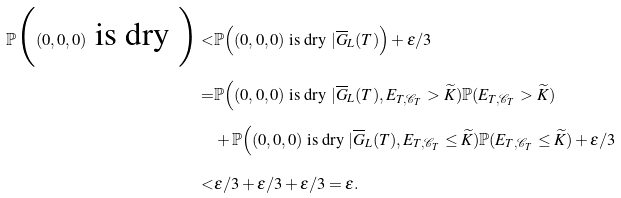Convert formula to latex. <formula><loc_0><loc_0><loc_500><loc_500>\mathbb { P } \Big ( ( 0 , 0 , 0 ) \text { is dry } \Big ) < & \mathbb { P } \Big ( ( 0 , 0 , 0 ) \text { is dry } | \overline { G } _ { L } ( T ) \Big ) + \epsilon / 3 \\ = & \mathbb { P } \Big ( ( 0 , 0 , 0 ) \text { is dry } | \overline { G } _ { L } ( T ) , E _ { T , \mathcal { C } _ { T } } > \widetilde { K } ) \mathbb { P } ( E _ { T , \mathcal { C } _ { T } } > \widetilde { K } ) \\ & + \mathbb { P } \Big ( ( 0 , 0 , 0 ) \text { is dry } | \overline { G } _ { L } ( T ) , E _ { T , \mathcal { C } _ { T } } \leq \widetilde { K } ) \mathbb { P } ( E _ { T , \mathcal { C } _ { T } } \leq \widetilde { K } ) + \epsilon / 3 \\ < & \epsilon / 3 + \epsilon / 3 + \epsilon / 3 = \epsilon .</formula> 